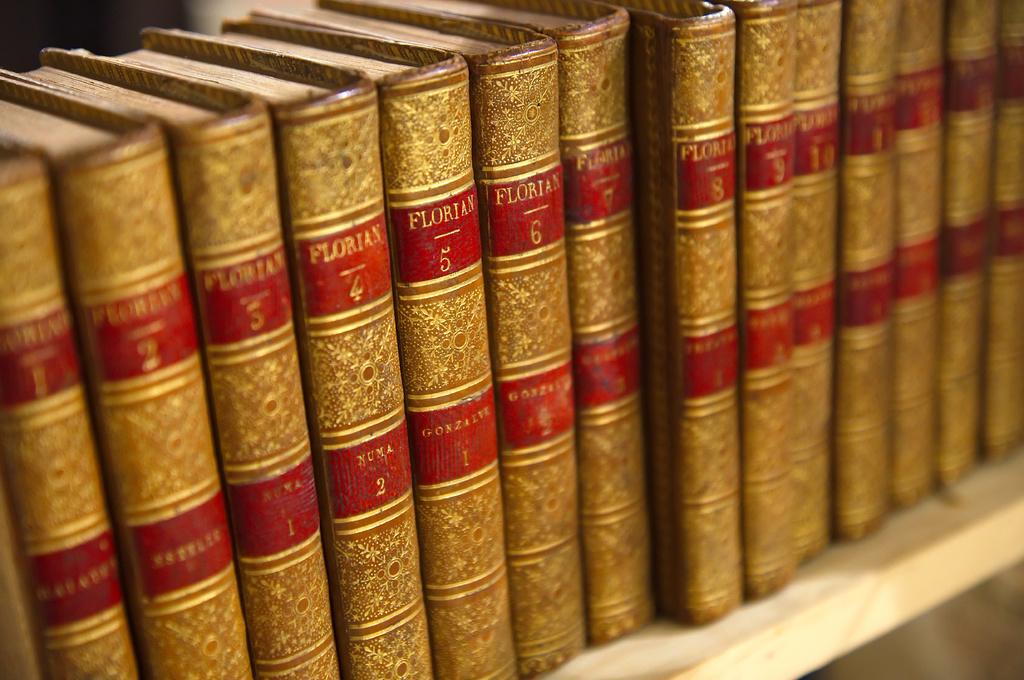What is the name printed at the top on each book?
Your response must be concise. Florian. 